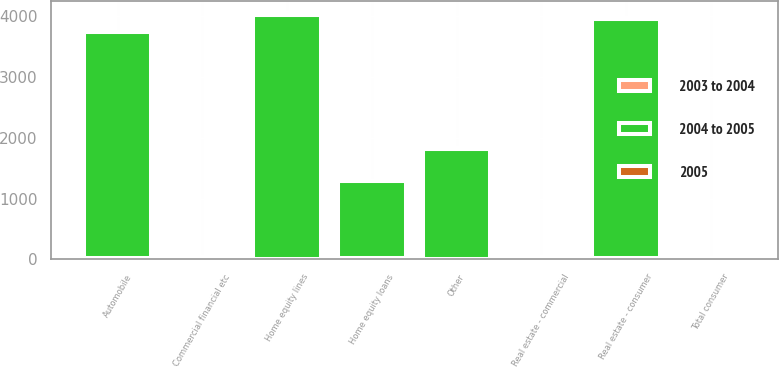Convert chart. <chart><loc_0><loc_0><loc_500><loc_500><stacked_bar_chart><ecel><fcel>Commercial financial etc<fcel>Real estate - commercial<fcel>Real estate - consumer<fcel>Automobile<fcel>Home equity lines<fcel>Home equity loans<fcel>Other<fcel>Total consumer<nl><fcel>2004 to 2005<fcel>15<fcel>15<fcel>3925<fcel>3716<fcel>4008<fcel>1271<fcel>1813<fcel>15<nl><fcel>2003 to 2004<fcel>10<fcel>8<fcel>26<fcel>16<fcel>13<fcel>17<fcel>6<fcel>4<nl><fcel>2005<fcel>12<fcel>15<fcel>18<fcel>10<fcel>25<fcel>6<fcel>7<fcel>11<nl></chart> 